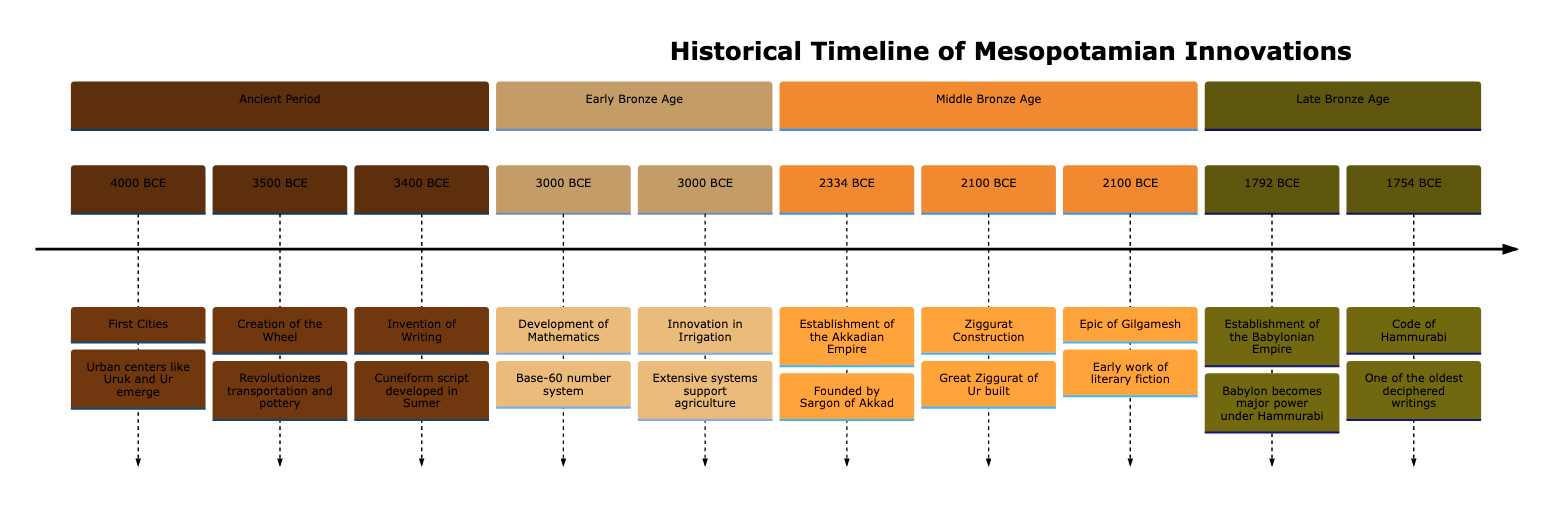What is the earliest cultural innovation mentioned in the timeline? The earliest date in the timeline is 4000 BCE, which corresponds to the emergence of the first cities in Mesopotamia.
Answer: First Cities Which significant writing was established in 1754 BCE? According to the timeline, the Code of Hammurabi was established in 1754 BCE, making it a significant written legacy from that period.
Answer: Code of Hammurabi How many major cultural innovations are listed in the ancient period? The ancient period contains three major innovations: First Cities, Creation of the Wheel, and Invention of Writing in the timeline.
Answer: 3 What notable structure was built around 2100 BCE? The timeline indicates that Ziggurat Construction, specifically the Great Ziggurat of Ur, occurred around 2100 BCE.
Answer: Ziggurat Construction Which empire was established first according to the timeline? The Akkadian Empire, founded by Sargon of Akkad, is noted in the timeline as being established in 2334 BCE, prior to the Babylonian Empire.
Answer: Akkadian Empire What is the significance of the date 3000 BCE in the timeline? At 3000 BCE, the timeline highlights two significant innovations: the Development of Mathematics and Innovation in Irrigation, which were crucial for Mesopotamian society.
Answer: Development of Mathematics and Innovation in Irrigation When were the first cities established? The timeline notes that urban centers like Uruk and Ur, which are recognized as the first cities, emerged around 4000 BCE.
Answer: 4000 BCE Which innovation revolutionized transportation in Mesopotamia? The timeline states that the Creation of the Wheel, which occurred around 3500 BCE, is recognized as the major innovation that revolutionized transportation.
Answer: Creation of the Wheel What year marks the establishment of the Babylonian Empire? In the timeline, the Babylonian Empire is marked as having been established in 1792 BCE, under the rule of Hammurabi.
Answer: 1792 BCE 